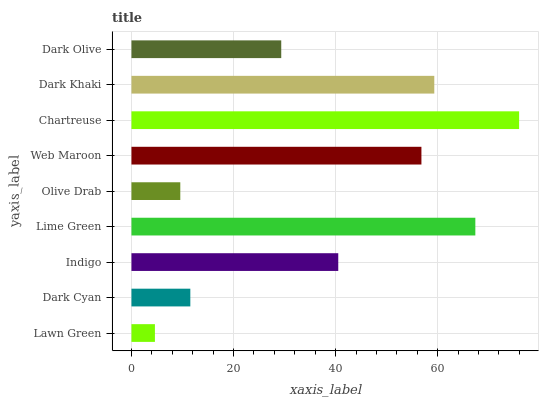Is Lawn Green the minimum?
Answer yes or no. Yes. Is Chartreuse the maximum?
Answer yes or no. Yes. Is Dark Cyan the minimum?
Answer yes or no. No. Is Dark Cyan the maximum?
Answer yes or no. No. Is Dark Cyan greater than Lawn Green?
Answer yes or no. Yes. Is Lawn Green less than Dark Cyan?
Answer yes or no. Yes. Is Lawn Green greater than Dark Cyan?
Answer yes or no. No. Is Dark Cyan less than Lawn Green?
Answer yes or no. No. Is Indigo the high median?
Answer yes or no. Yes. Is Indigo the low median?
Answer yes or no. Yes. Is Dark Olive the high median?
Answer yes or no. No. Is Olive Drab the low median?
Answer yes or no. No. 